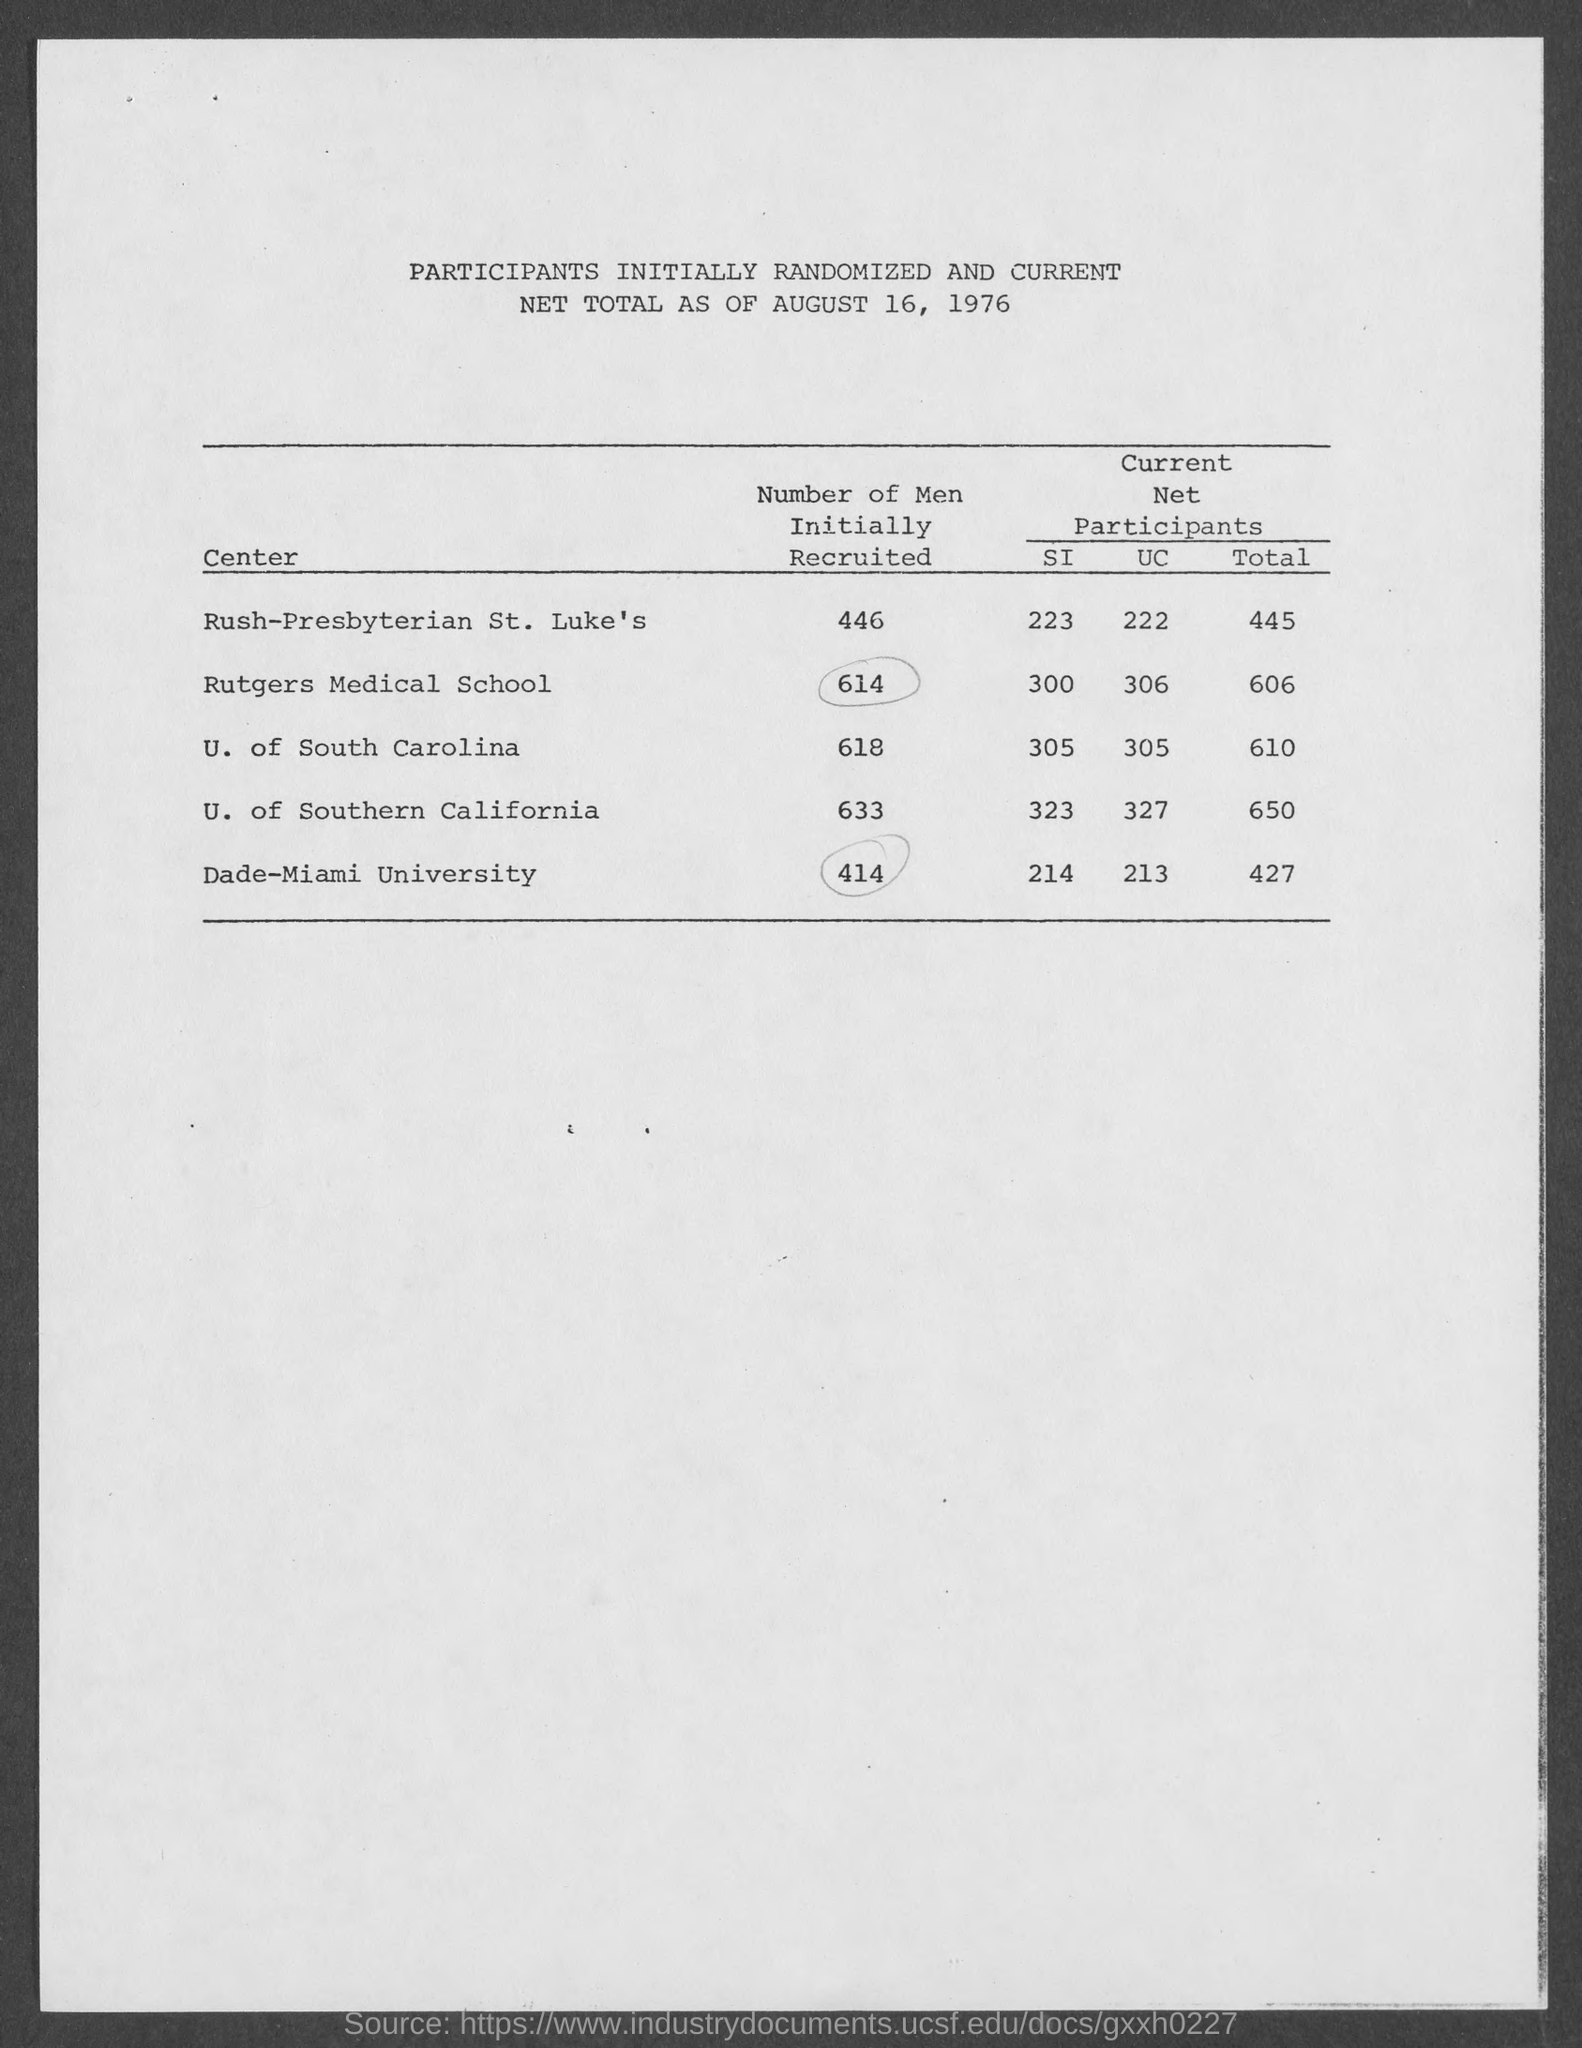Number of Men initially recruited in center  " U. of South Carolina" ?
Make the answer very short. 618. Number of Men initially recruited in center  "U. of Southern California"?
Ensure brevity in your answer.  633. Number of Men initially recruited in center "Dade-Miami University"?
Keep it short and to the point. 414. 